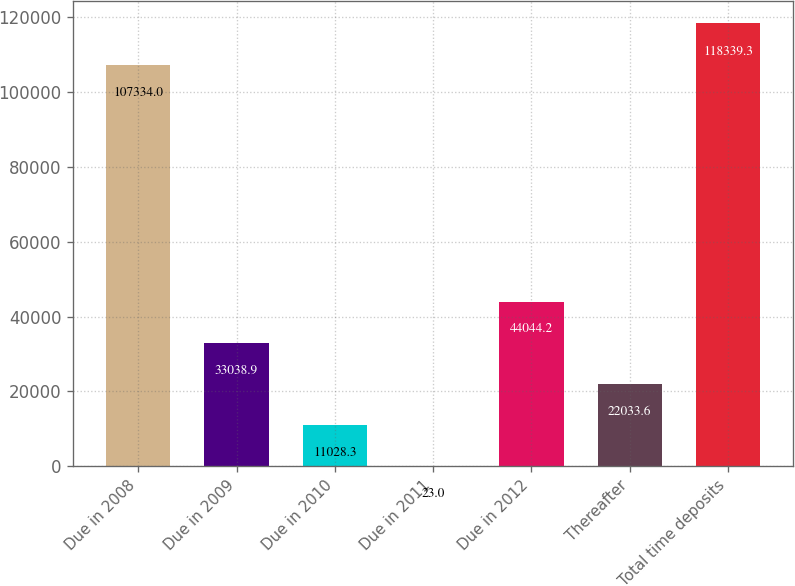Convert chart. <chart><loc_0><loc_0><loc_500><loc_500><bar_chart><fcel>Due in 2008<fcel>Due in 2009<fcel>Due in 2010<fcel>Due in 2011<fcel>Due in 2012<fcel>Thereafter<fcel>Total time deposits<nl><fcel>107334<fcel>33038.9<fcel>11028.3<fcel>23<fcel>44044.2<fcel>22033.6<fcel>118339<nl></chart> 